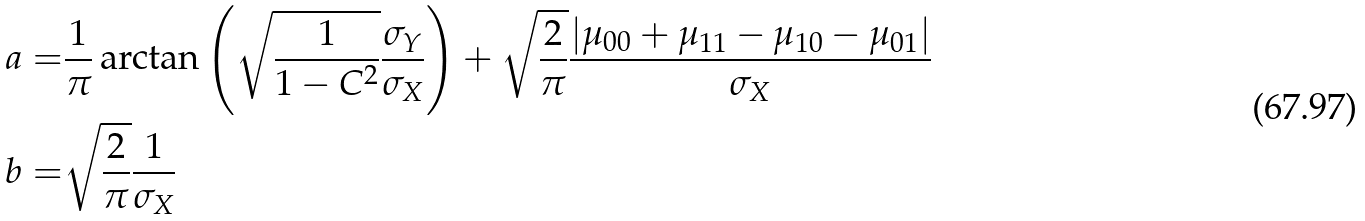<formula> <loc_0><loc_0><loc_500><loc_500>a = & \frac { 1 } { \pi } \arctan \left ( \sqrt { \frac { 1 } { 1 - C ^ { 2 } } } \frac { \sigma _ { Y } } { \sigma _ { X } } \right ) + \sqrt { \frac { 2 } { \pi } } \frac { | \mu _ { 0 0 } + \mu _ { 1 1 } - \mu _ { 1 0 } - \mu _ { 0 1 } | } { \sigma _ { X } } \\ b = & \sqrt { \frac { 2 } { \pi } } \frac { 1 } { \sigma _ { X } }</formula> 